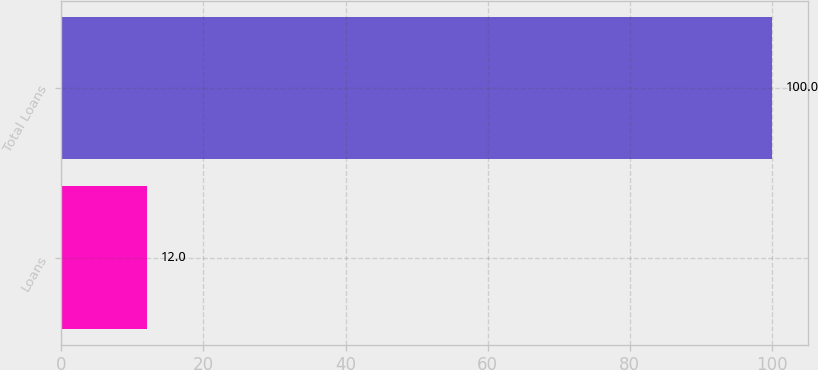Convert chart to OTSL. <chart><loc_0><loc_0><loc_500><loc_500><bar_chart><fcel>Loans<fcel>Total Loans<nl><fcel>12<fcel>100<nl></chart> 